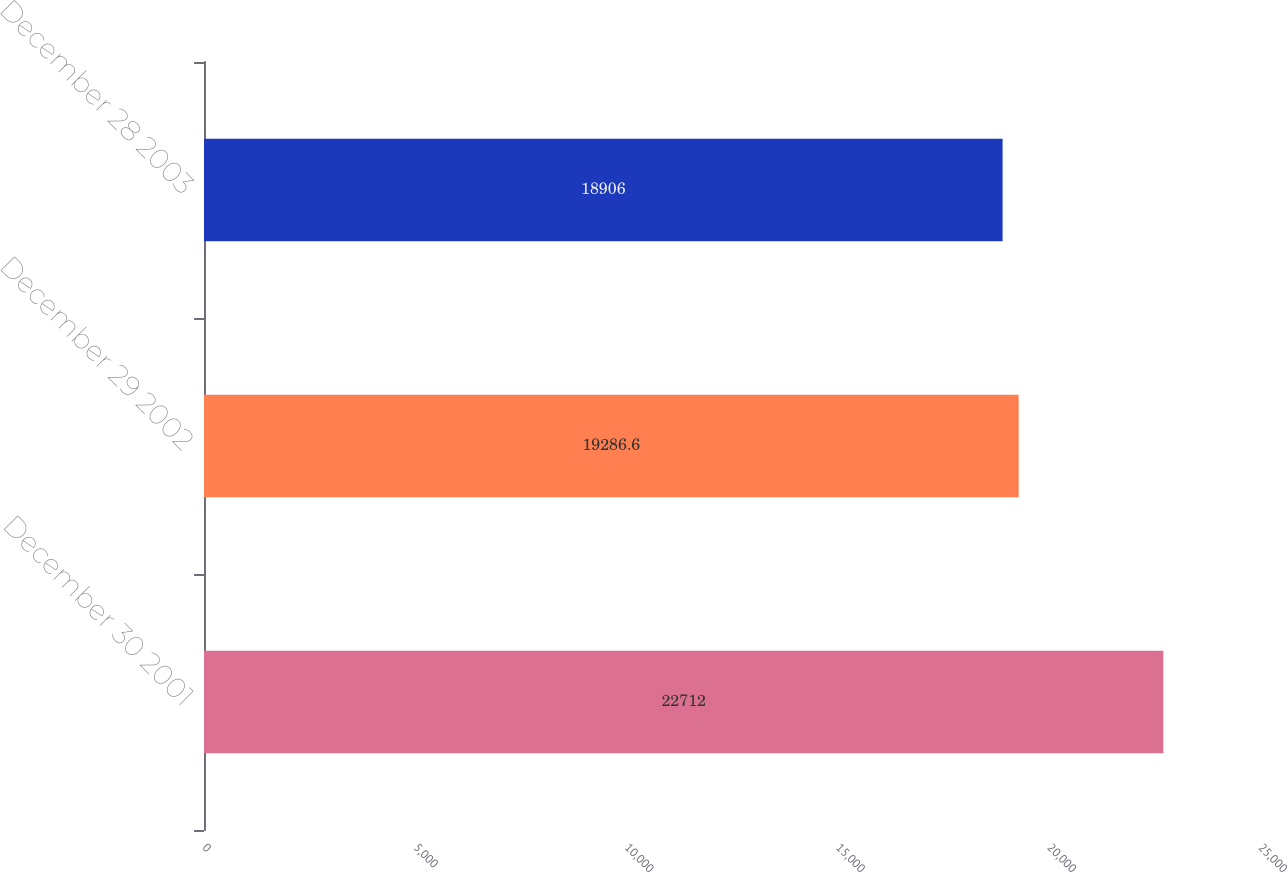Convert chart. <chart><loc_0><loc_0><loc_500><loc_500><bar_chart><fcel>December 30 2001<fcel>December 29 2002<fcel>December 28 2003<nl><fcel>22712<fcel>19286.6<fcel>18906<nl></chart> 